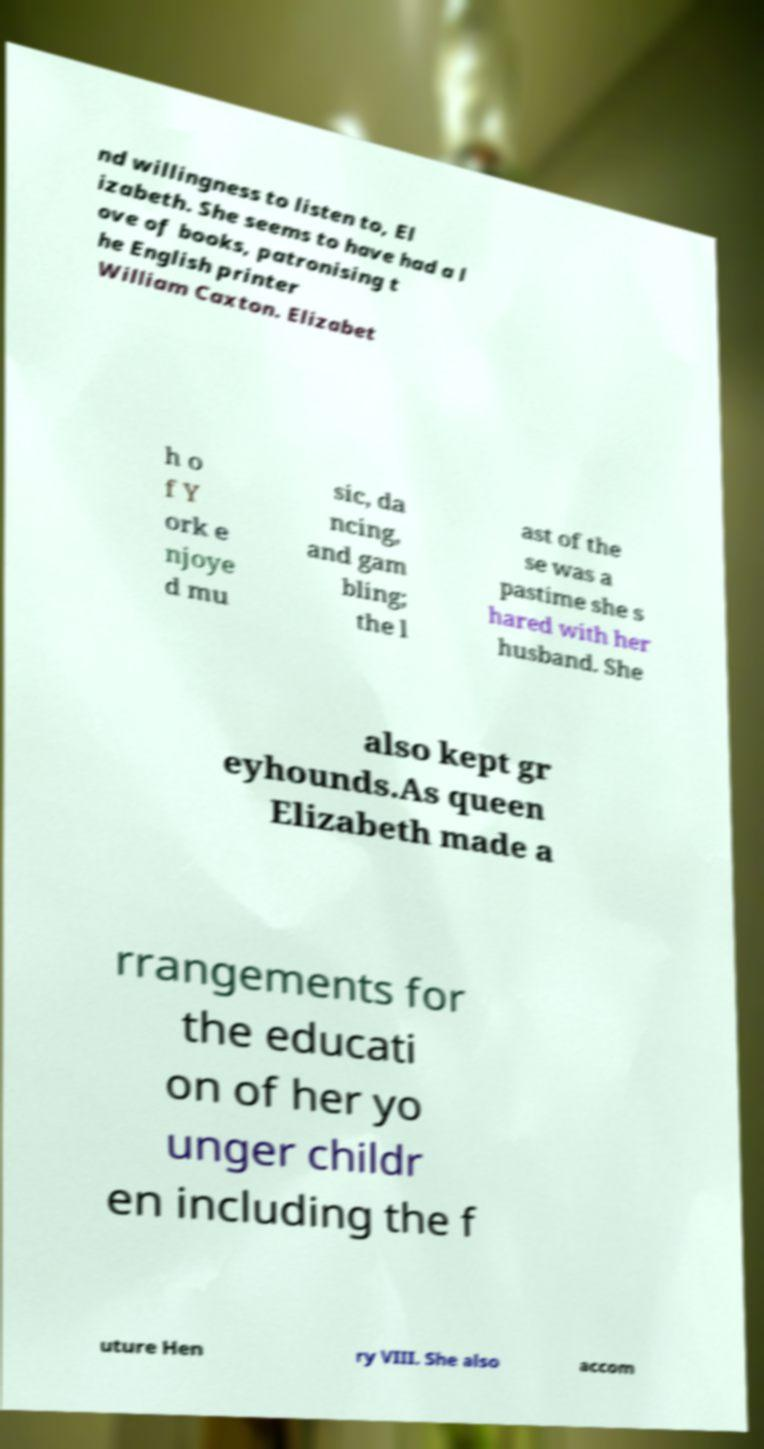Could you extract and type out the text from this image? nd willingness to listen to, El izabeth. She seems to have had a l ove of books, patronising t he English printer William Caxton. Elizabet h o f Y ork e njoye d mu sic, da ncing, and gam bling; the l ast of the se was a pastime she s hared with her husband. She also kept gr eyhounds.As queen Elizabeth made a rrangements for the educati on of her yo unger childr en including the f uture Hen ry VIII. She also accom 